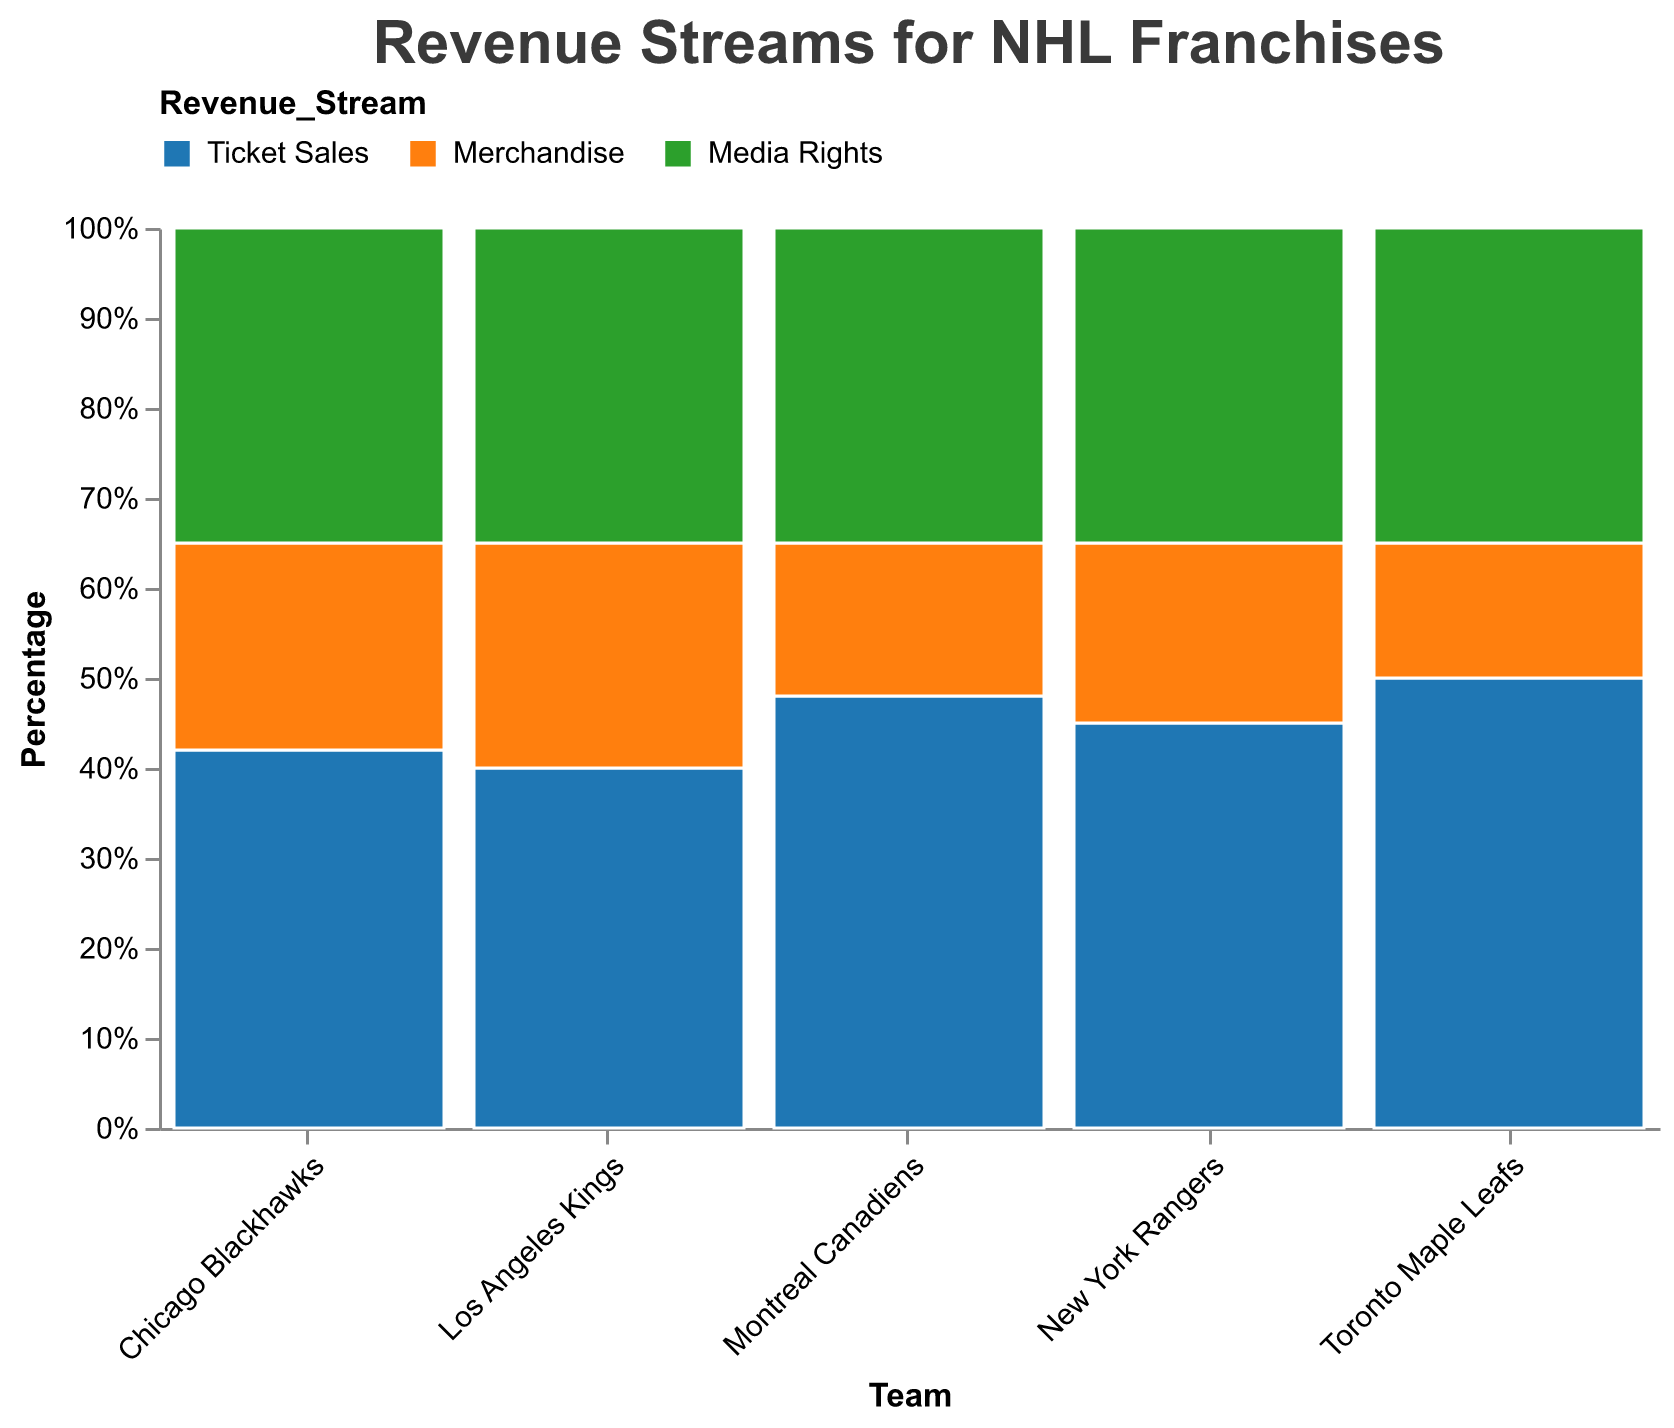What are the primary revenue streams visualized in the plot? The plot shows three primary revenue streams: Ticket Sales, Merchandise, and Media Rights. These are depicted using different colors.
Answer: Ticket Sales, Merchandise, Media Rights Which team has the highest percentage of revenue from Ticket Sales? By looking at the height of Ticket Sales segments across teams, the Toronto Maple Leafs have the tallest section, indicating 50% revenue from Ticket Sales.
Answer: Toronto Maple Leafs How would you describe the revenue distribution of the New York Rangers? The New York Rangers have 45% from Ticket Sales, 20% from Merchandise, and 35% from Media Rights. This distribution is shown by the proportional heights of the segments within the team's bar.
Answer: 45% Ticket Sales, 20% Merchandise, 35% Media Rights Are there any teams that share the same percentage for Media Rights? Yes, the Media Rights percentages for all teams are equal at 35%. This can be seen as the Media Rights segments for all teams align horizontally.
Answer: Yes, all teams (35%) Which team has the smallest percentage revenue from Merchandise? The Toronto Maple Leafs have the smallest Merchandise percentage, represented by the shortest Merchandise segment at 15%.
Answer: Toronto Maple Leafs Compare the ticket sales percentage between Los Angeles Kings and Chicago Blackhawks. Los Angeles Kings have 40% revenue from Ticket Sales while Chicago Blackhawks have 42%. Comparing these segments, Chicago Blackhawks have a slightly higher percentage.
Answer: Chicago Blackhawks What is the overall trend in revenue distribution among the teams? Most teams have the largest percentage from Ticket Sales, followed by Media Rights and then Merchandise. This trend is visible by comparing the relative heights of each segment across all teams.
Answer: Ticket Sales > Media Rights > Merchandise If you sum the percentages of Merchandise and Media Rights for the Montreal Canadiens, what value do you get? For the Montreal Canadiens, Merchandise is 17% and Media Rights is 35%. Adding these, 17% + 35% = 52%.
Answer: 52% Which revenue stream has the most consistent percentage across all teams? Media Rights has the most consistent percentage, consistently at 35% for all teams. This uniform representation is evidenced by the equal height of Media Rights segments across all teams.
Answer: Media Rights Which two teams have the closest percentages in Ticket Sales revenue? Chicago Blackhawks at 42% and Los Angeles Kings at 40% are closest in Ticket Sales revenue. Their Ticket Sales segments are nearly equal in height.
Answer: Chicago Blackhawks and Los Angeles Kings 